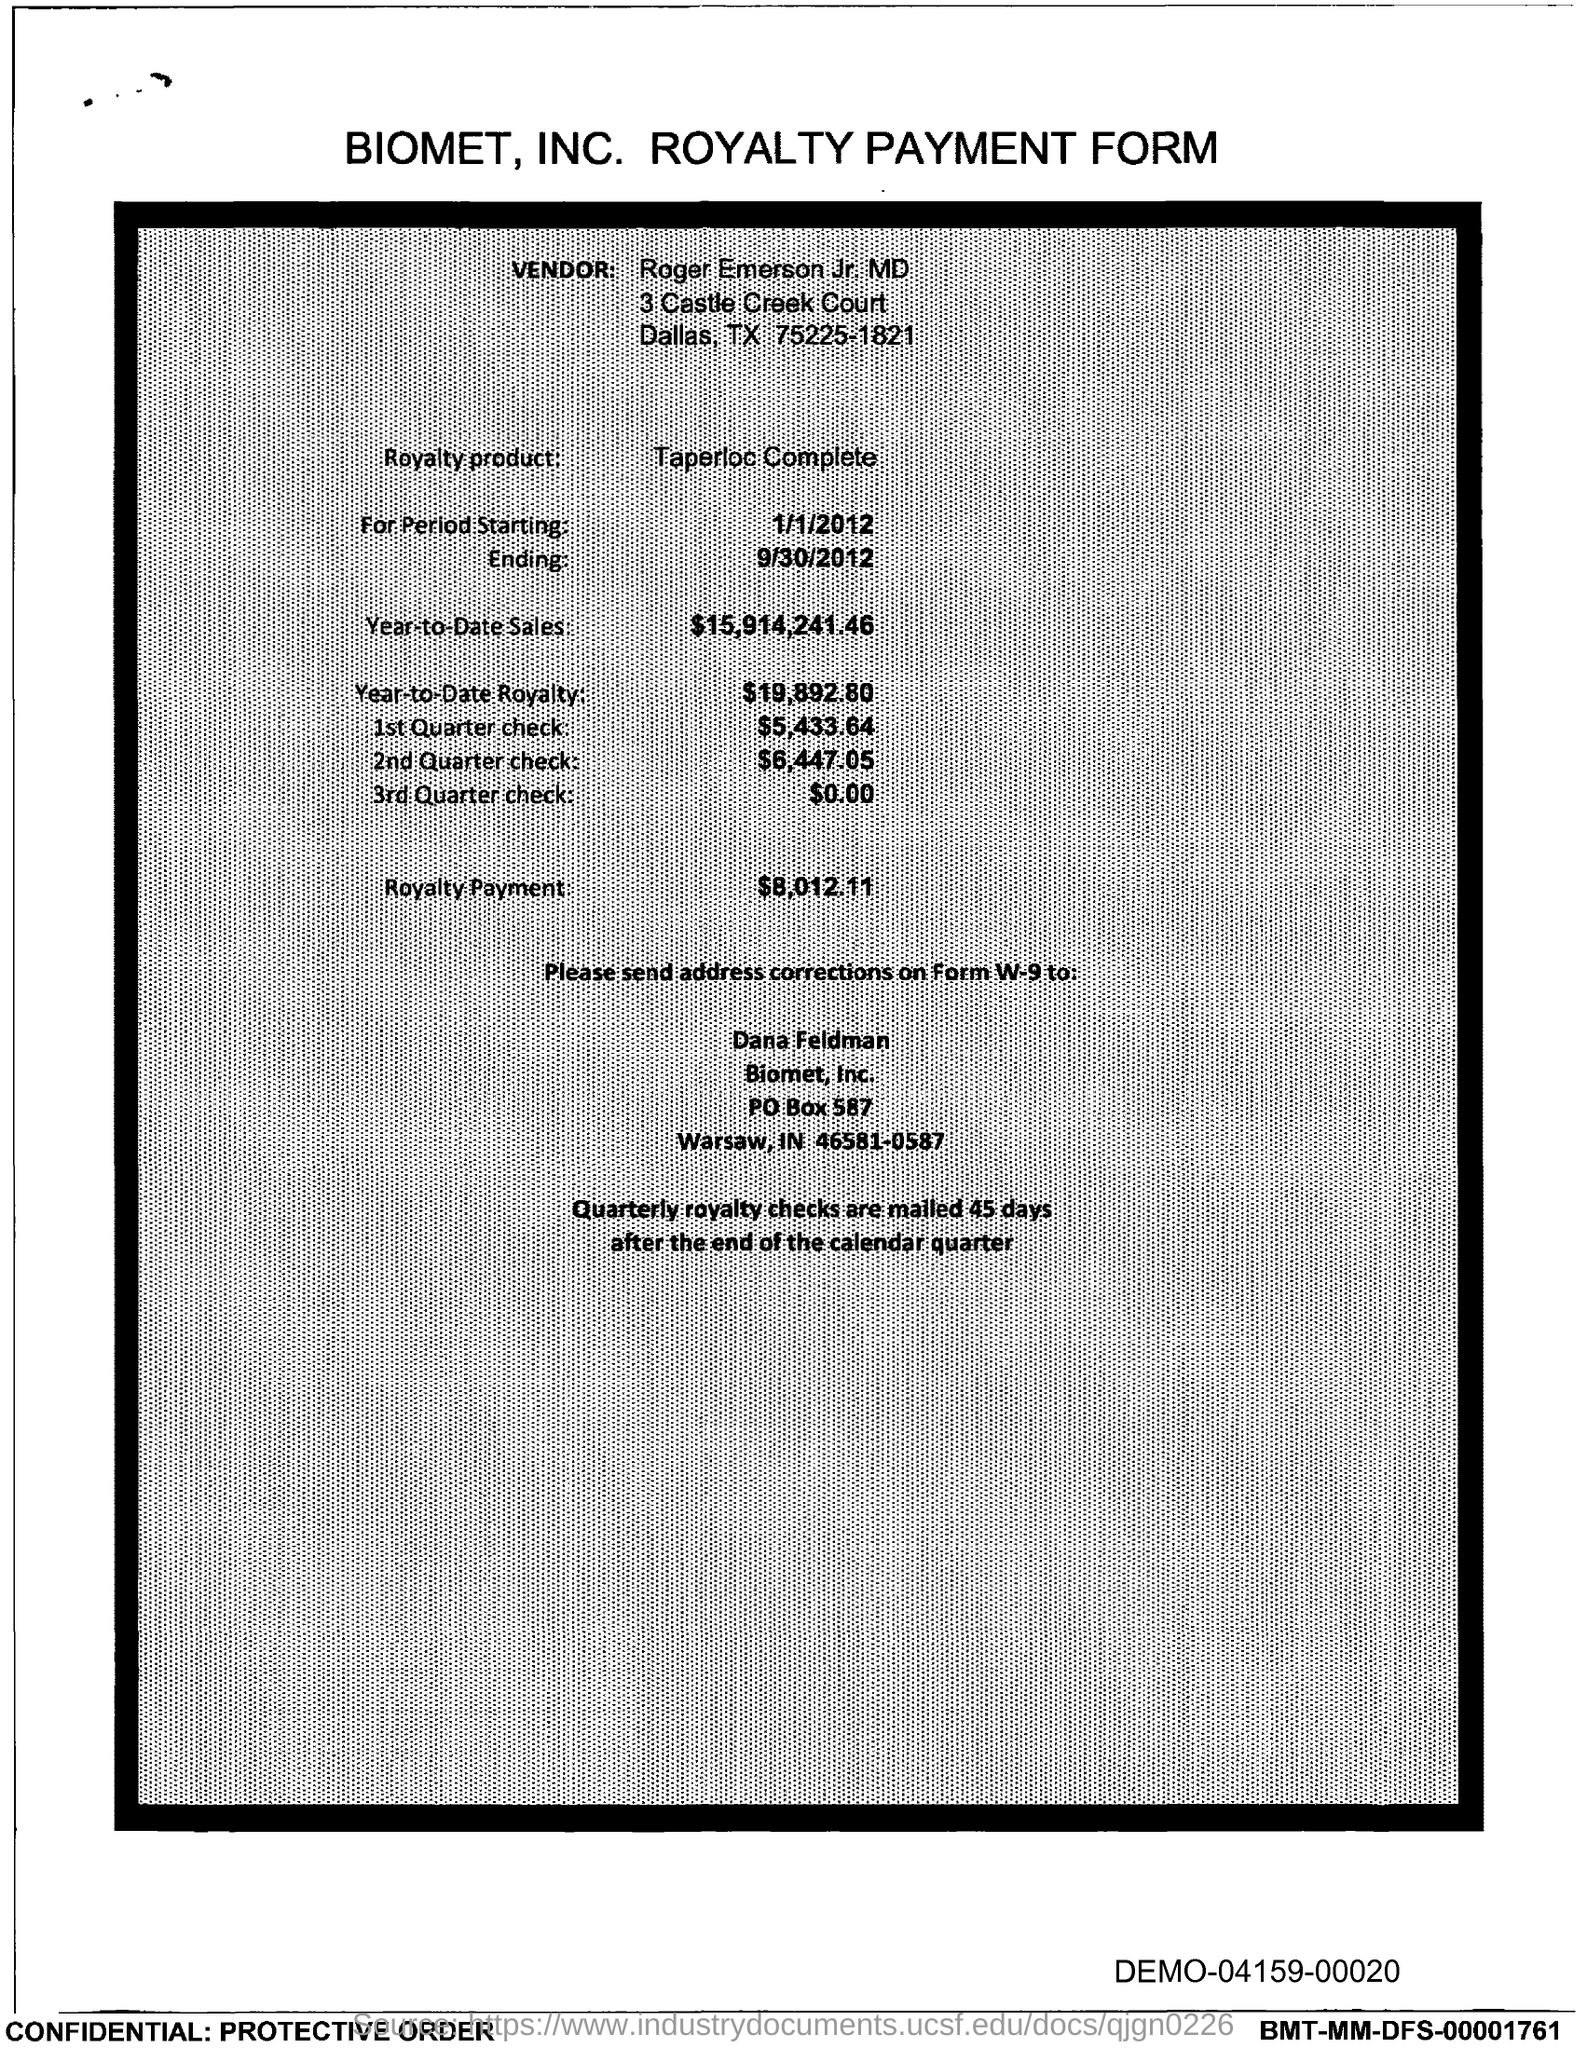What is the title of this form?
Give a very brief answer. BIOMET. INC. ROYALTY PAYMENT FORM. What is the vendor name mentioned in this form?
Keep it short and to the point. Roger Emerson jr. MD. What is the Year-to-Date Sales mentioned in this document?
Ensure brevity in your answer.  $15,914,241.46. 